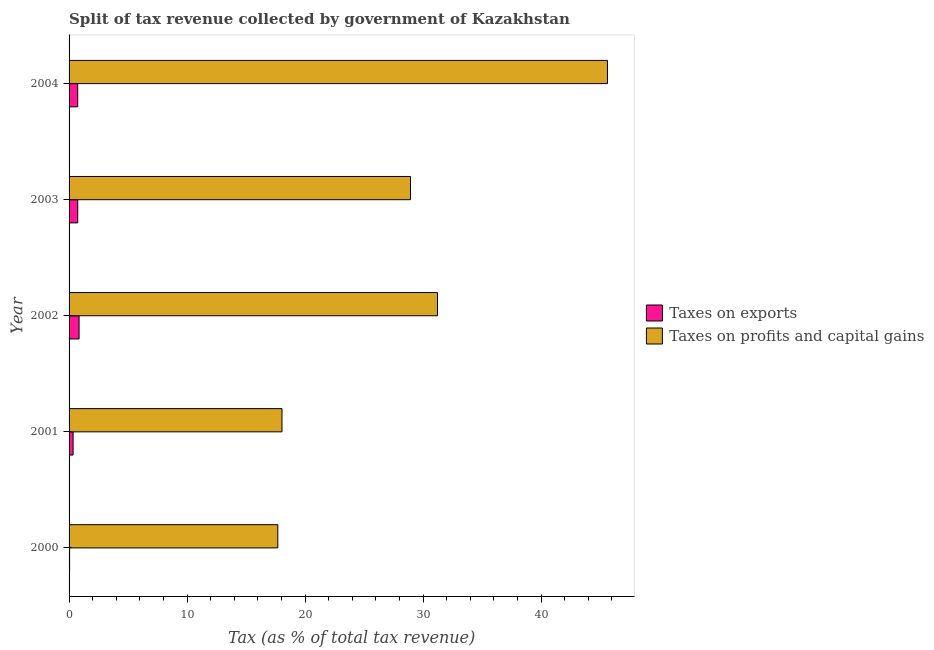How many different coloured bars are there?
Offer a very short reply. 2. How many bars are there on the 2nd tick from the bottom?
Your response must be concise. 2. What is the label of the 1st group of bars from the top?
Your response must be concise. 2004. In how many cases, is the number of bars for a given year not equal to the number of legend labels?
Provide a short and direct response. 0. What is the percentage of revenue obtained from taxes on profits and capital gains in 2002?
Your response must be concise. 31.22. Across all years, what is the maximum percentage of revenue obtained from taxes on exports?
Give a very brief answer. 0.85. Across all years, what is the minimum percentage of revenue obtained from taxes on exports?
Provide a succinct answer. 0.05. In which year was the percentage of revenue obtained from taxes on profits and capital gains maximum?
Keep it short and to the point. 2004. What is the total percentage of revenue obtained from taxes on exports in the graph?
Make the answer very short. 2.7. What is the difference between the percentage of revenue obtained from taxes on exports in 2002 and that in 2004?
Your answer should be compact. 0.12. What is the difference between the percentage of revenue obtained from taxes on exports in 2000 and the percentage of revenue obtained from taxes on profits and capital gains in 2001?
Your answer should be very brief. -18. What is the average percentage of revenue obtained from taxes on exports per year?
Offer a terse response. 0.54. In the year 2001, what is the difference between the percentage of revenue obtained from taxes on profits and capital gains and percentage of revenue obtained from taxes on exports?
Give a very brief answer. 17.7. In how many years, is the percentage of revenue obtained from taxes on exports greater than 22 %?
Make the answer very short. 0. Is the percentage of revenue obtained from taxes on profits and capital gains in 2000 less than that in 2001?
Your answer should be compact. Yes. What is the difference between the highest and the second highest percentage of revenue obtained from taxes on profits and capital gains?
Keep it short and to the point. 14.4. In how many years, is the percentage of revenue obtained from taxes on exports greater than the average percentage of revenue obtained from taxes on exports taken over all years?
Ensure brevity in your answer.  3. What does the 2nd bar from the top in 2000 represents?
Your answer should be very brief. Taxes on exports. What does the 1st bar from the bottom in 2004 represents?
Your response must be concise. Taxes on exports. How many years are there in the graph?
Offer a terse response. 5. Are the values on the major ticks of X-axis written in scientific E-notation?
Make the answer very short. No. Does the graph contain grids?
Ensure brevity in your answer.  No. How are the legend labels stacked?
Your response must be concise. Vertical. What is the title of the graph?
Your answer should be compact. Split of tax revenue collected by government of Kazakhstan. What is the label or title of the X-axis?
Your response must be concise. Tax (as % of total tax revenue). What is the label or title of the Y-axis?
Offer a very short reply. Year. What is the Tax (as % of total tax revenue) of Taxes on exports in 2000?
Provide a short and direct response. 0.05. What is the Tax (as % of total tax revenue) of Taxes on profits and capital gains in 2000?
Your response must be concise. 17.69. What is the Tax (as % of total tax revenue) of Taxes on exports in 2001?
Offer a very short reply. 0.34. What is the Tax (as % of total tax revenue) in Taxes on profits and capital gains in 2001?
Provide a succinct answer. 18.04. What is the Tax (as % of total tax revenue) in Taxes on exports in 2002?
Offer a very short reply. 0.85. What is the Tax (as % of total tax revenue) in Taxes on profits and capital gains in 2002?
Provide a succinct answer. 31.22. What is the Tax (as % of total tax revenue) in Taxes on exports in 2003?
Offer a terse response. 0.73. What is the Tax (as % of total tax revenue) in Taxes on profits and capital gains in 2003?
Offer a very short reply. 28.93. What is the Tax (as % of total tax revenue) of Taxes on exports in 2004?
Your answer should be compact. 0.73. What is the Tax (as % of total tax revenue) of Taxes on profits and capital gains in 2004?
Offer a terse response. 45.62. Across all years, what is the maximum Tax (as % of total tax revenue) of Taxes on exports?
Your response must be concise. 0.85. Across all years, what is the maximum Tax (as % of total tax revenue) in Taxes on profits and capital gains?
Your answer should be very brief. 45.62. Across all years, what is the minimum Tax (as % of total tax revenue) in Taxes on exports?
Give a very brief answer. 0.05. Across all years, what is the minimum Tax (as % of total tax revenue) in Taxes on profits and capital gains?
Offer a terse response. 17.69. What is the total Tax (as % of total tax revenue) in Taxes on exports in the graph?
Your answer should be very brief. 2.7. What is the total Tax (as % of total tax revenue) of Taxes on profits and capital gains in the graph?
Provide a short and direct response. 141.5. What is the difference between the Tax (as % of total tax revenue) in Taxes on exports in 2000 and that in 2001?
Your answer should be very brief. -0.3. What is the difference between the Tax (as % of total tax revenue) of Taxes on profits and capital gains in 2000 and that in 2001?
Ensure brevity in your answer.  -0.35. What is the difference between the Tax (as % of total tax revenue) in Taxes on exports in 2000 and that in 2002?
Ensure brevity in your answer.  -0.8. What is the difference between the Tax (as % of total tax revenue) of Taxes on profits and capital gains in 2000 and that in 2002?
Your response must be concise. -13.53. What is the difference between the Tax (as % of total tax revenue) of Taxes on exports in 2000 and that in 2003?
Keep it short and to the point. -0.69. What is the difference between the Tax (as % of total tax revenue) in Taxes on profits and capital gains in 2000 and that in 2003?
Your response must be concise. -11.24. What is the difference between the Tax (as % of total tax revenue) in Taxes on exports in 2000 and that in 2004?
Provide a short and direct response. -0.69. What is the difference between the Tax (as % of total tax revenue) in Taxes on profits and capital gains in 2000 and that in 2004?
Give a very brief answer. -27.93. What is the difference between the Tax (as % of total tax revenue) of Taxes on exports in 2001 and that in 2002?
Make the answer very short. -0.51. What is the difference between the Tax (as % of total tax revenue) of Taxes on profits and capital gains in 2001 and that in 2002?
Give a very brief answer. -13.18. What is the difference between the Tax (as % of total tax revenue) of Taxes on exports in 2001 and that in 2003?
Provide a short and direct response. -0.39. What is the difference between the Tax (as % of total tax revenue) of Taxes on profits and capital gains in 2001 and that in 2003?
Your answer should be very brief. -10.89. What is the difference between the Tax (as % of total tax revenue) in Taxes on exports in 2001 and that in 2004?
Your answer should be compact. -0.39. What is the difference between the Tax (as % of total tax revenue) in Taxes on profits and capital gains in 2001 and that in 2004?
Your answer should be very brief. -27.58. What is the difference between the Tax (as % of total tax revenue) of Taxes on exports in 2002 and that in 2003?
Your answer should be compact. 0.11. What is the difference between the Tax (as % of total tax revenue) in Taxes on profits and capital gains in 2002 and that in 2003?
Ensure brevity in your answer.  2.29. What is the difference between the Tax (as % of total tax revenue) of Taxes on exports in 2002 and that in 2004?
Offer a terse response. 0.12. What is the difference between the Tax (as % of total tax revenue) of Taxes on profits and capital gains in 2002 and that in 2004?
Give a very brief answer. -14.4. What is the difference between the Tax (as % of total tax revenue) of Taxes on exports in 2003 and that in 2004?
Offer a very short reply. 0. What is the difference between the Tax (as % of total tax revenue) in Taxes on profits and capital gains in 2003 and that in 2004?
Your answer should be compact. -16.69. What is the difference between the Tax (as % of total tax revenue) of Taxes on exports in 2000 and the Tax (as % of total tax revenue) of Taxes on profits and capital gains in 2001?
Ensure brevity in your answer.  -18. What is the difference between the Tax (as % of total tax revenue) of Taxes on exports in 2000 and the Tax (as % of total tax revenue) of Taxes on profits and capital gains in 2002?
Keep it short and to the point. -31.17. What is the difference between the Tax (as % of total tax revenue) in Taxes on exports in 2000 and the Tax (as % of total tax revenue) in Taxes on profits and capital gains in 2003?
Your response must be concise. -28.89. What is the difference between the Tax (as % of total tax revenue) of Taxes on exports in 2000 and the Tax (as % of total tax revenue) of Taxes on profits and capital gains in 2004?
Your response must be concise. -45.58. What is the difference between the Tax (as % of total tax revenue) of Taxes on exports in 2001 and the Tax (as % of total tax revenue) of Taxes on profits and capital gains in 2002?
Offer a terse response. -30.88. What is the difference between the Tax (as % of total tax revenue) of Taxes on exports in 2001 and the Tax (as % of total tax revenue) of Taxes on profits and capital gains in 2003?
Offer a terse response. -28.59. What is the difference between the Tax (as % of total tax revenue) in Taxes on exports in 2001 and the Tax (as % of total tax revenue) in Taxes on profits and capital gains in 2004?
Give a very brief answer. -45.28. What is the difference between the Tax (as % of total tax revenue) of Taxes on exports in 2002 and the Tax (as % of total tax revenue) of Taxes on profits and capital gains in 2003?
Give a very brief answer. -28.08. What is the difference between the Tax (as % of total tax revenue) in Taxes on exports in 2002 and the Tax (as % of total tax revenue) in Taxes on profits and capital gains in 2004?
Keep it short and to the point. -44.77. What is the difference between the Tax (as % of total tax revenue) of Taxes on exports in 2003 and the Tax (as % of total tax revenue) of Taxes on profits and capital gains in 2004?
Your answer should be very brief. -44.89. What is the average Tax (as % of total tax revenue) of Taxes on exports per year?
Provide a succinct answer. 0.54. What is the average Tax (as % of total tax revenue) of Taxes on profits and capital gains per year?
Give a very brief answer. 28.3. In the year 2000, what is the difference between the Tax (as % of total tax revenue) in Taxes on exports and Tax (as % of total tax revenue) in Taxes on profits and capital gains?
Provide a short and direct response. -17.64. In the year 2001, what is the difference between the Tax (as % of total tax revenue) of Taxes on exports and Tax (as % of total tax revenue) of Taxes on profits and capital gains?
Ensure brevity in your answer.  -17.7. In the year 2002, what is the difference between the Tax (as % of total tax revenue) in Taxes on exports and Tax (as % of total tax revenue) in Taxes on profits and capital gains?
Make the answer very short. -30.37. In the year 2003, what is the difference between the Tax (as % of total tax revenue) in Taxes on exports and Tax (as % of total tax revenue) in Taxes on profits and capital gains?
Keep it short and to the point. -28.2. In the year 2004, what is the difference between the Tax (as % of total tax revenue) of Taxes on exports and Tax (as % of total tax revenue) of Taxes on profits and capital gains?
Your response must be concise. -44.89. What is the ratio of the Tax (as % of total tax revenue) of Taxes on exports in 2000 to that in 2001?
Keep it short and to the point. 0.13. What is the ratio of the Tax (as % of total tax revenue) of Taxes on profits and capital gains in 2000 to that in 2001?
Make the answer very short. 0.98. What is the ratio of the Tax (as % of total tax revenue) of Taxes on exports in 2000 to that in 2002?
Your answer should be very brief. 0.05. What is the ratio of the Tax (as % of total tax revenue) of Taxes on profits and capital gains in 2000 to that in 2002?
Your response must be concise. 0.57. What is the ratio of the Tax (as % of total tax revenue) of Taxes on exports in 2000 to that in 2003?
Ensure brevity in your answer.  0.06. What is the ratio of the Tax (as % of total tax revenue) in Taxes on profits and capital gains in 2000 to that in 2003?
Offer a very short reply. 0.61. What is the ratio of the Tax (as % of total tax revenue) of Taxes on exports in 2000 to that in 2004?
Offer a very short reply. 0.06. What is the ratio of the Tax (as % of total tax revenue) of Taxes on profits and capital gains in 2000 to that in 2004?
Offer a very short reply. 0.39. What is the ratio of the Tax (as % of total tax revenue) of Taxes on exports in 2001 to that in 2002?
Ensure brevity in your answer.  0.4. What is the ratio of the Tax (as % of total tax revenue) in Taxes on profits and capital gains in 2001 to that in 2002?
Ensure brevity in your answer.  0.58. What is the ratio of the Tax (as % of total tax revenue) of Taxes on exports in 2001 to that in 2003?
Provide a succinct answer. 0.47. What is the ratio of the Tax (as % of total tax revenue) in Taxes on profits and capital gains in 2001 to that in 2003?
Give a very brief answer. 0.62. What is the ratio of the Tax (as % of total tax revenue) in Taxes on exports in 2001 to that in 2004?
Ensure brevity in your answer.  0.47. What is the ratio of the Tax (as % of total tax revenue) in Taxes on profits and capital gains in 2001 to that in 2004?
Your response must be concise. 0.4. What is the ratio of the Tax (as % of total tax revenue) in Taxes on exports in 2002 to that in 2003?
Offer a very short reply. 1.15. What is the ratio of the Tax (as % of total tax revenue) of Taxes on profits and capital gains in 2002 to that in 2003?
Make the answer very short. 1.08. What is the ratio of the Tax (as % of total tax revenue) in Taxes on exports in 2002 to that in 2004?
Your response must be concise. 1.16. What is the ratio of the Tax (as % of total tax revenue) of Taxes on profits and capital gains in 2002 to that in 2004?
Your answer should be very brief. 0.68. What is the ratio of the Tax (as % of total tax revenue) in Taxes on profits and capital gains in 2003 to that in 2004?
Your response must be concise. 0.63. What is the difference between the highest and the second highest Tax (as % of total tax revenue) of Taxes on exports?
Your response must be concise. 0.11. What is the difference between the highest and the second highest Tax (as % of total tax revenue) of Taxes on profits and capital gains?
Keep it short and to the point. 14.4. What is the difference between the highest and the lowest Tax (as % of total tax revenue) of Taxes on exports?
Keep it short and to the point. 0.8. What is the difference between the highest and the lowest Tax (as % of total tax revenue) of Taxes on profits and capital gains?
Keep it short and to the point. 27.93. 